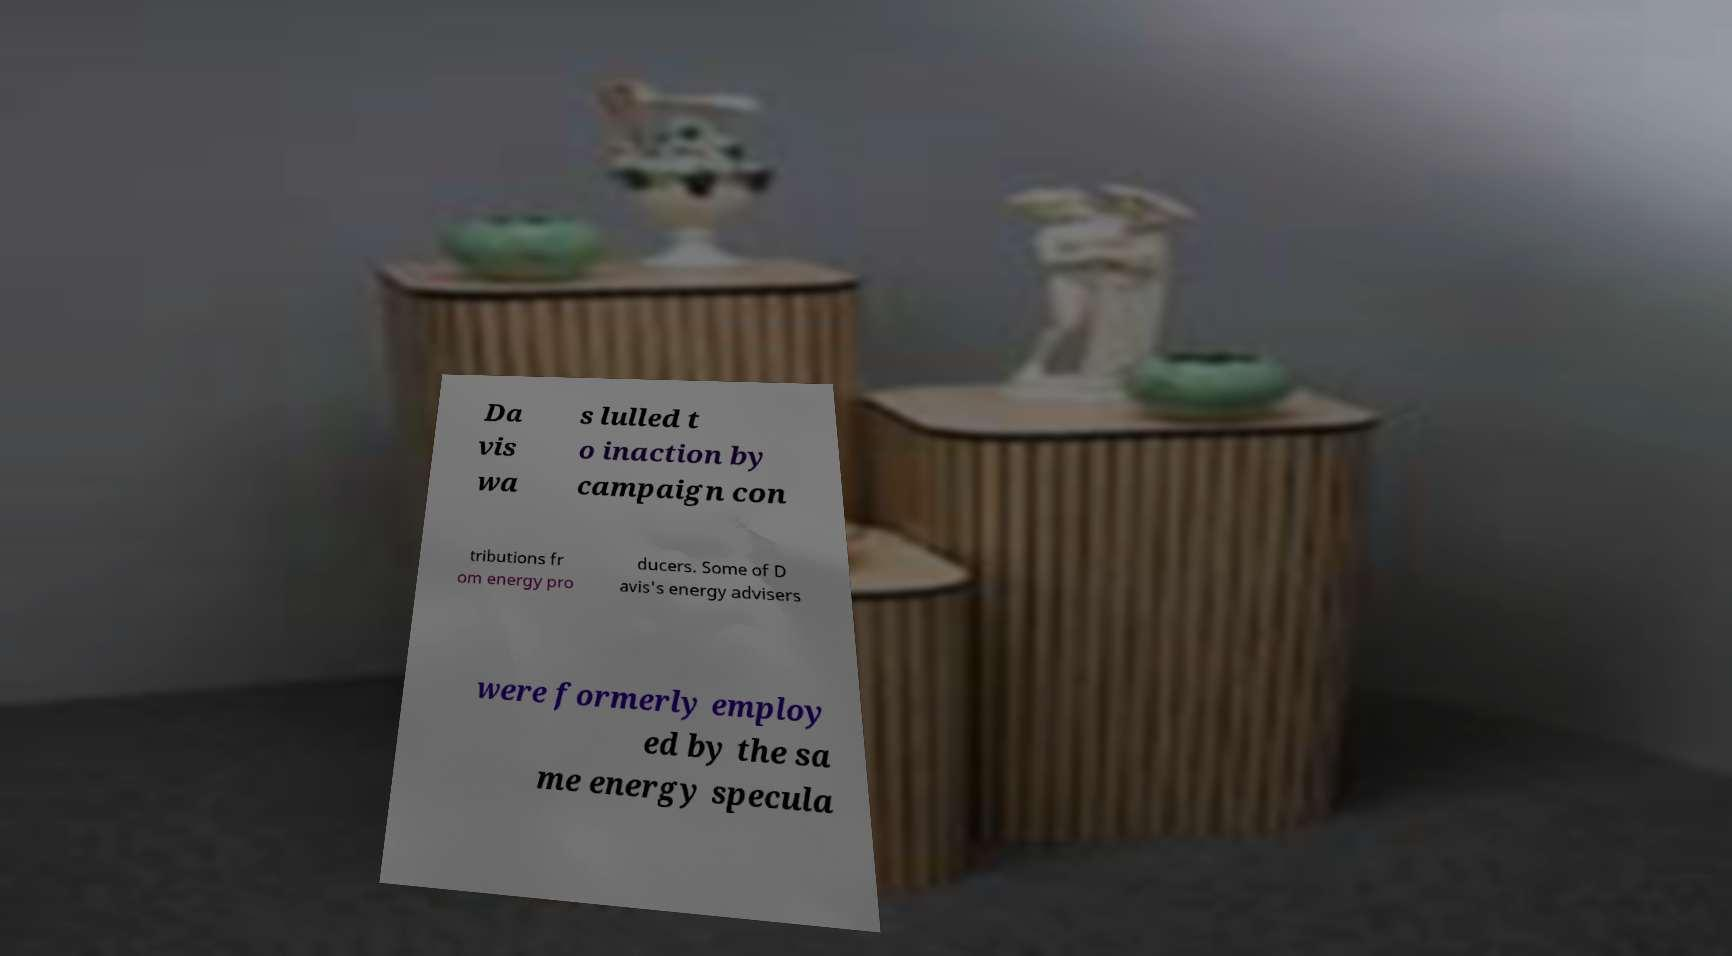There's text embedded in this image that I need extracted. Can you transcribe it verbatim? Da vis wa s lulled t o inaction by campaign con tributions fr om energy pro ducers. Some of D avis's energy advisers were formerly employ ed by the sa me energy specula 